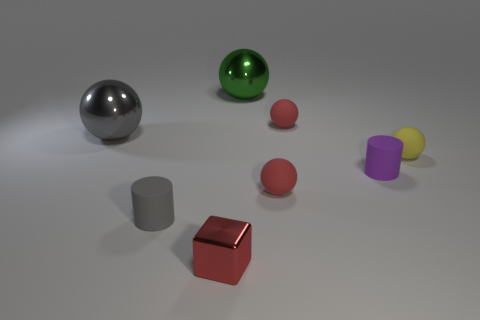There is a red metal cube; is it the same size as the sphere left of the tiny cube?
Your answer should be very brief. No. How many matte spheres have the same color as the metal block?
Provide a succinct answer. 2. What number of things are either small purple cylinders or tiny things that are on the left side of the small purple matte object?
Provide a succinct answer. 5. There is a gray thing that is behind the gray matte cylinder; is it the same size as the gray object in front of the small purple rubber cylinder?
Make the answer very short. No. Is there a big red cylinder that has the same material as the gray ball?
Your answer should be very brief. No. What is the shape of the large green object?
Your answer should be compact. Sphere. There is a metal thing to the right of the cube that is in front of the tiny purple rubber thing; what is its shape?
Your answer should be very brief. Sphere. How many other things are there of the same shape as the gray metallic object?
Keep it short and to the point. 4. There is a cylinder that is on the left side of the metallic thing that is in front of the yellow ball; how big is it?
Your response must be concise. Small. Is there a large gray rubber object?
Offer a terse response. No. 